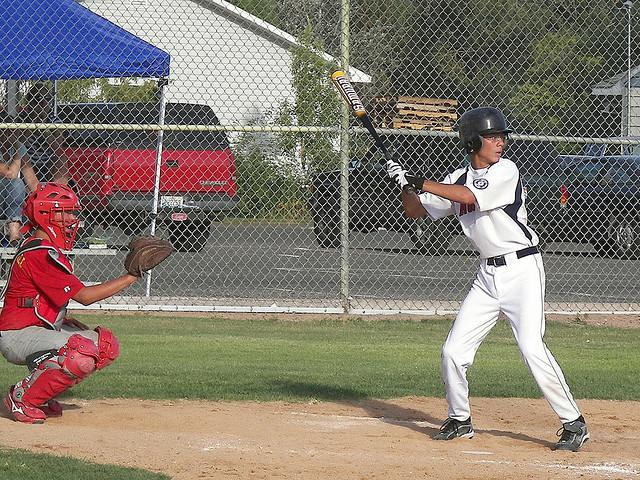Why is he holding the bat behind him? preparing swing 